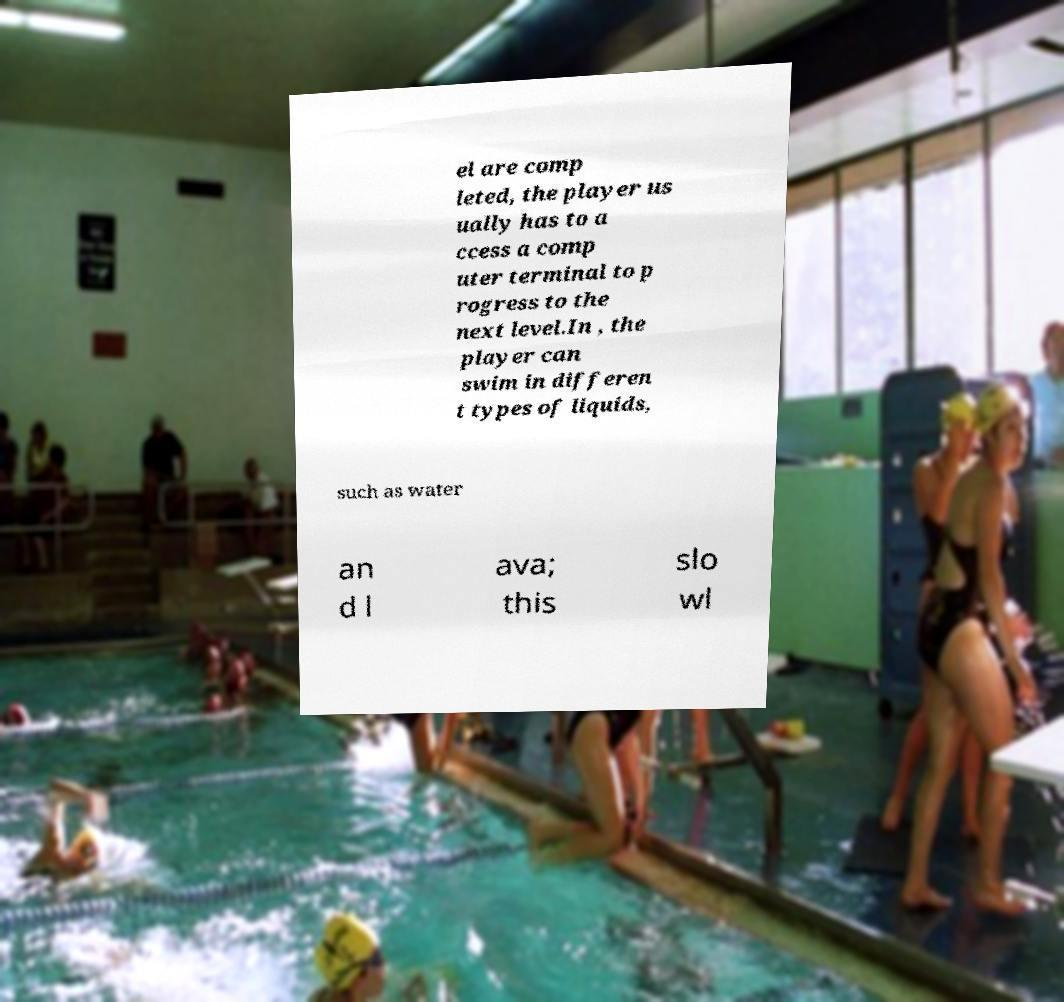What messages or text are displayed in this image? I need them in a readable, typed format. el are comp leted, the player us ually has to a ccess a comp uter terminal to p rogress to the next level.In , the player can swim in differen t types of liquids, such as water an d l ava; this slo wl 